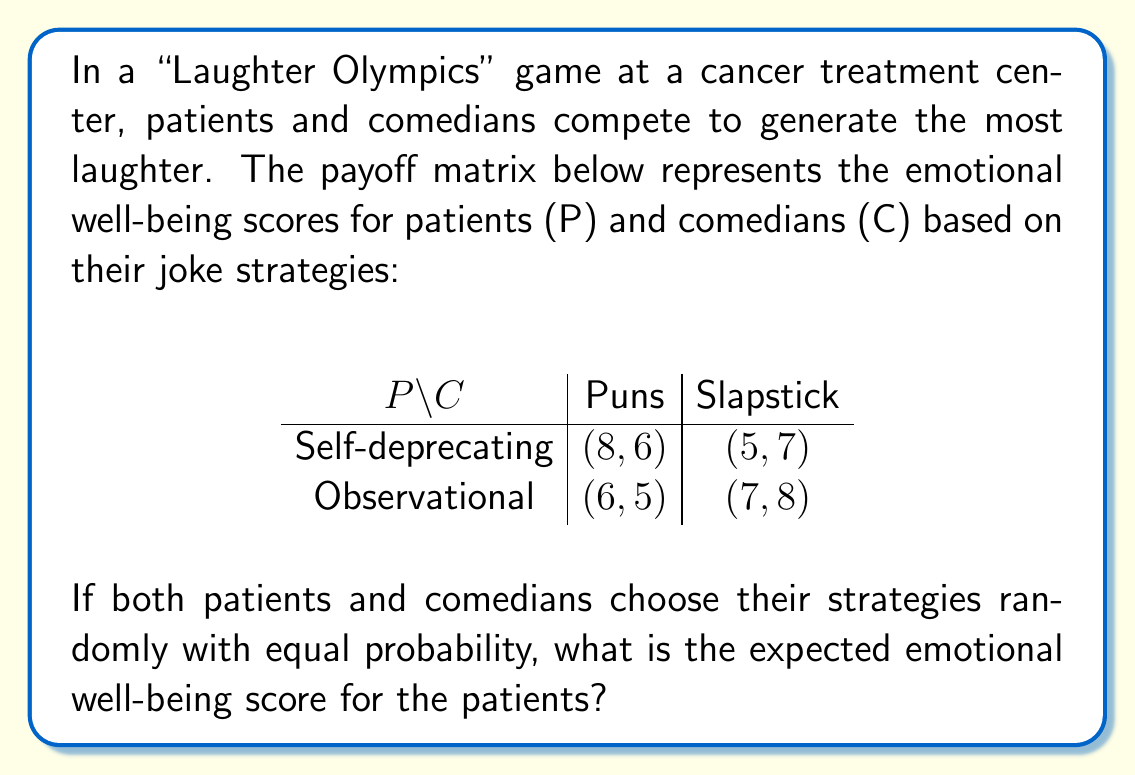What is the answer to this math problem? To solve this problem, we'll follow these steps:

1) First, let's identify the probabilities of each strategy:
   - Patients: P(Self-deprecating) = P(Observational) = 0.5
   - Comedians: P(Puns) = P(Slapstick) = 0.5

2) Now, let's calculate the expected value for each outcome:

   a) (Self-deprecating, Puns): 
      $E_1 = 8 \times 0.5 \times 0.5 = 2$

   b) (Self-deprecating, Slapstick): 
      $E_2 = 5 \times 0.5 \times 0.5 = 1.25$

   c) (Observational, Puns): 
      $E_3 = 6 \times 0.5 \times 0.5 = 1.5$

   d) (Observational, Slapstick): 
      $E_4 = 7 \times 0.5 \times 0.5 = 1.75$

3) The total expected emotional well-being score for patients is the sum of these individual expectations:

   $E_{total} = E_1 + E_2 + E_3 + E_4$
   $E_{total} = 2 + 1.25 + 1.5 + 1.75 = 6.5$

Therefore, the expected emotional well-being score for the patients is 6.5.

This result suggests that, on average, patients can expect a moderately high emotional well-being score from participating in the "Laughter Olympics", regardless of the strategies chosen. This aligns with the persona of a cancer patient seeking emotional relief through humor therapy.
Answer: The expected emotional well-being score for the patients is 6.5. 